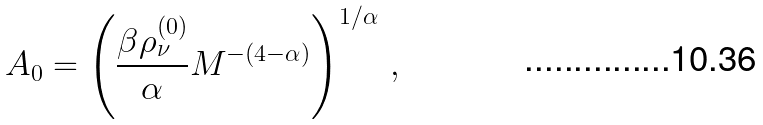<formula> <loc_0><loc_0><loc_500><loc_500>A _ { 0 } = \left ( \frac { \beta \rho _ { \nu } ^ { ( 0 ) } } { \alpha } M ^ { - ( 4 - \alpha ) } \right ) ^ { 1 / \alpha } \, ,</formula> 